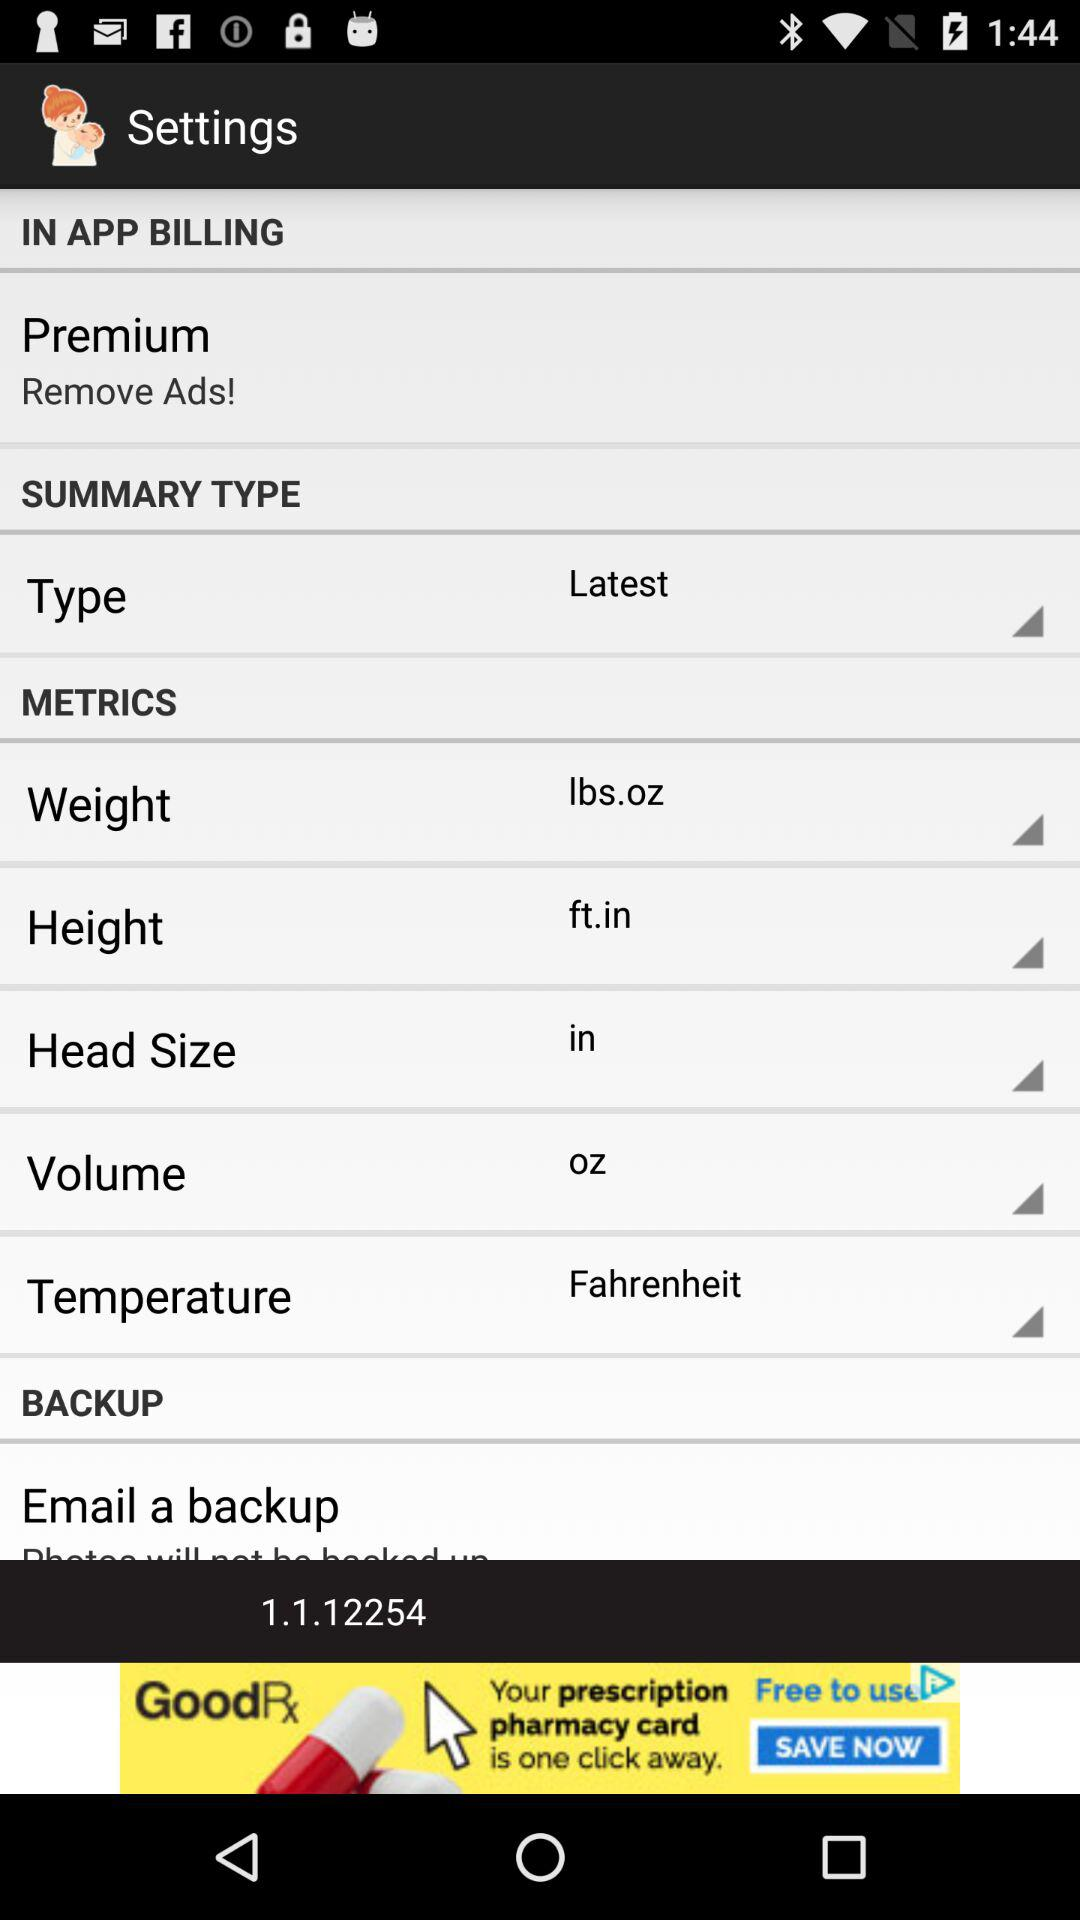What is the selected measurement unit of height on the application? The selected measurement unit of height is feet and inches. 